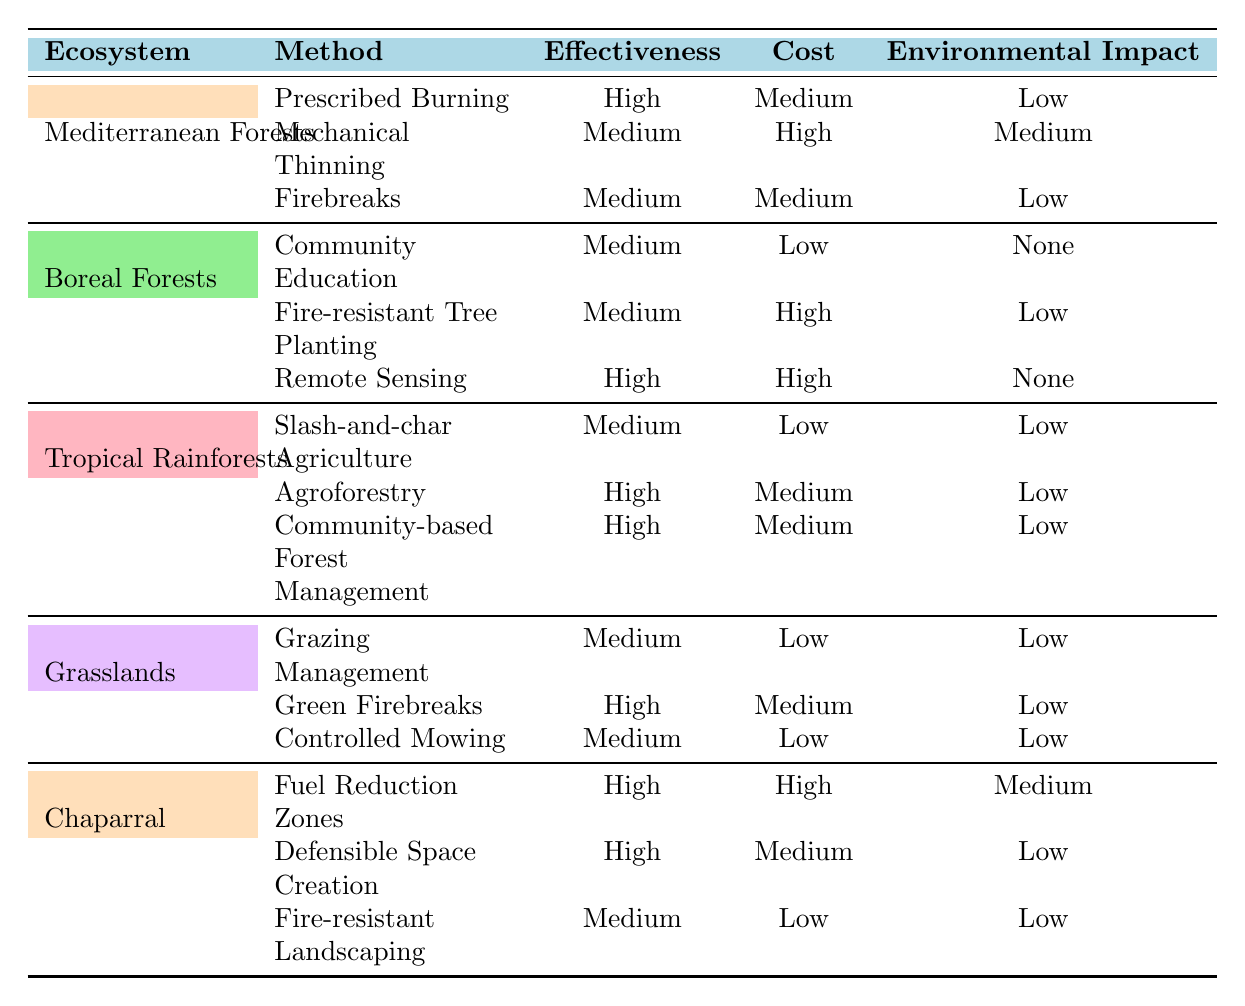What ecosystem has the highest effectiveness for wildfire prevention? The ecosystems with the highest effectiveness methods are Mediterranean Forests, Tropical Rainforests, and Chaparral, each having methods rated as "High." Since more than one ecosystem has the highest effectiveness, we conclude that multiple ecosystems display this characteristic.
Answer: Mediterranean Forests, Tropical Rainforests, and Chaparral Which wildfire prevention technique has the highest cost in the Mediterranean Forests? In the Mediterranean Forests, the techniques are Prescribed Burning (Medium cost), Mechanical Thinning (High cost), and Firebreaks (Medium cost). The method with the highest cost is Mechanical Thinning.
Answer: Mechanical Thinning Is Community Education an effective wildfire prevention technique in Boreal Forests? Community Education in Boreal Forests has an effectiveness rating of "Medium," indicating it is not considered highly effective. Therefore, it does not stand out as a top-tier technique.
Answer: No How many methods exhibit "High" environmental impact across all listed ecosystems? In the table, the methods have the following environmental impacts: Mediterranean Forests have 2 Low and 1 Medium, Boreal Forests have 2 Low and 1 None, Tropical Rainforests have 3 Low, Grasslands have 3 Low, and Chaparral has 1 Medium, 2 Low. There are no methods rated as "High" for environmental impact, so the total is 0.
Answer: 0 What is the average effectiveness rating for wildfire prevention methods in Grasslands? In Grasslands, the techniques and their effectiveness are Grazing Management (Medium), Green Firebreaks (High), and Controlled Mowing (Medium). First, we assign numerical values (High=2, Medium=1, Low=0), resulting in 1 (Medium) + 2 (High) + 1 (Medium) = 4. Since there are 3 methods, the average effectiveness is 4/3 = 1.33, which corresponds to a Medium effectiveness on average.
Answer: Medium Which prevention technique has the lowest cost in the Tropical Rainforests? In Tropical Rainforests, the techniques are Slash-and-char Agriculture (Low cost), Agroforestry (Medium cost), and Community-based Forest Management (Medium cost). The method with the lowest cost is Slash-and-char Agriculture.
Answer: Slash-and-char Agriculture How does the cost of Fire-resistant Tree Planting in Boreal Forests compare with the highest cost method in the Chaparral? Fire-resistant Tree Planting in Boreal Forests has a High cost. In Chaparral, the highest cost method is Fuel Reduction Zones, which also has a High cost. Therefore, both methods have the same cost level, even though we do not know their exact numerical values.
Answer: Same Which ecosystem has the lowest average cost for its prevention methods? The costs for all methods in each ecosystem need to be calculated. Mediterranean Forests have (Medium, High, Medium), Boreal Forests have (Low, High, High), Tropical Rainforests have (Low, Medium, Medium), Grasslands have (Low, Medium, Low), and Chaparral have (High, Medium, Low). Upon counting the number of Low, Medium, and High, Grasslands demonstrate the lowest average cost method distribution, because it has a larger proportion of Low cost methods.
Answer: Grasslands 